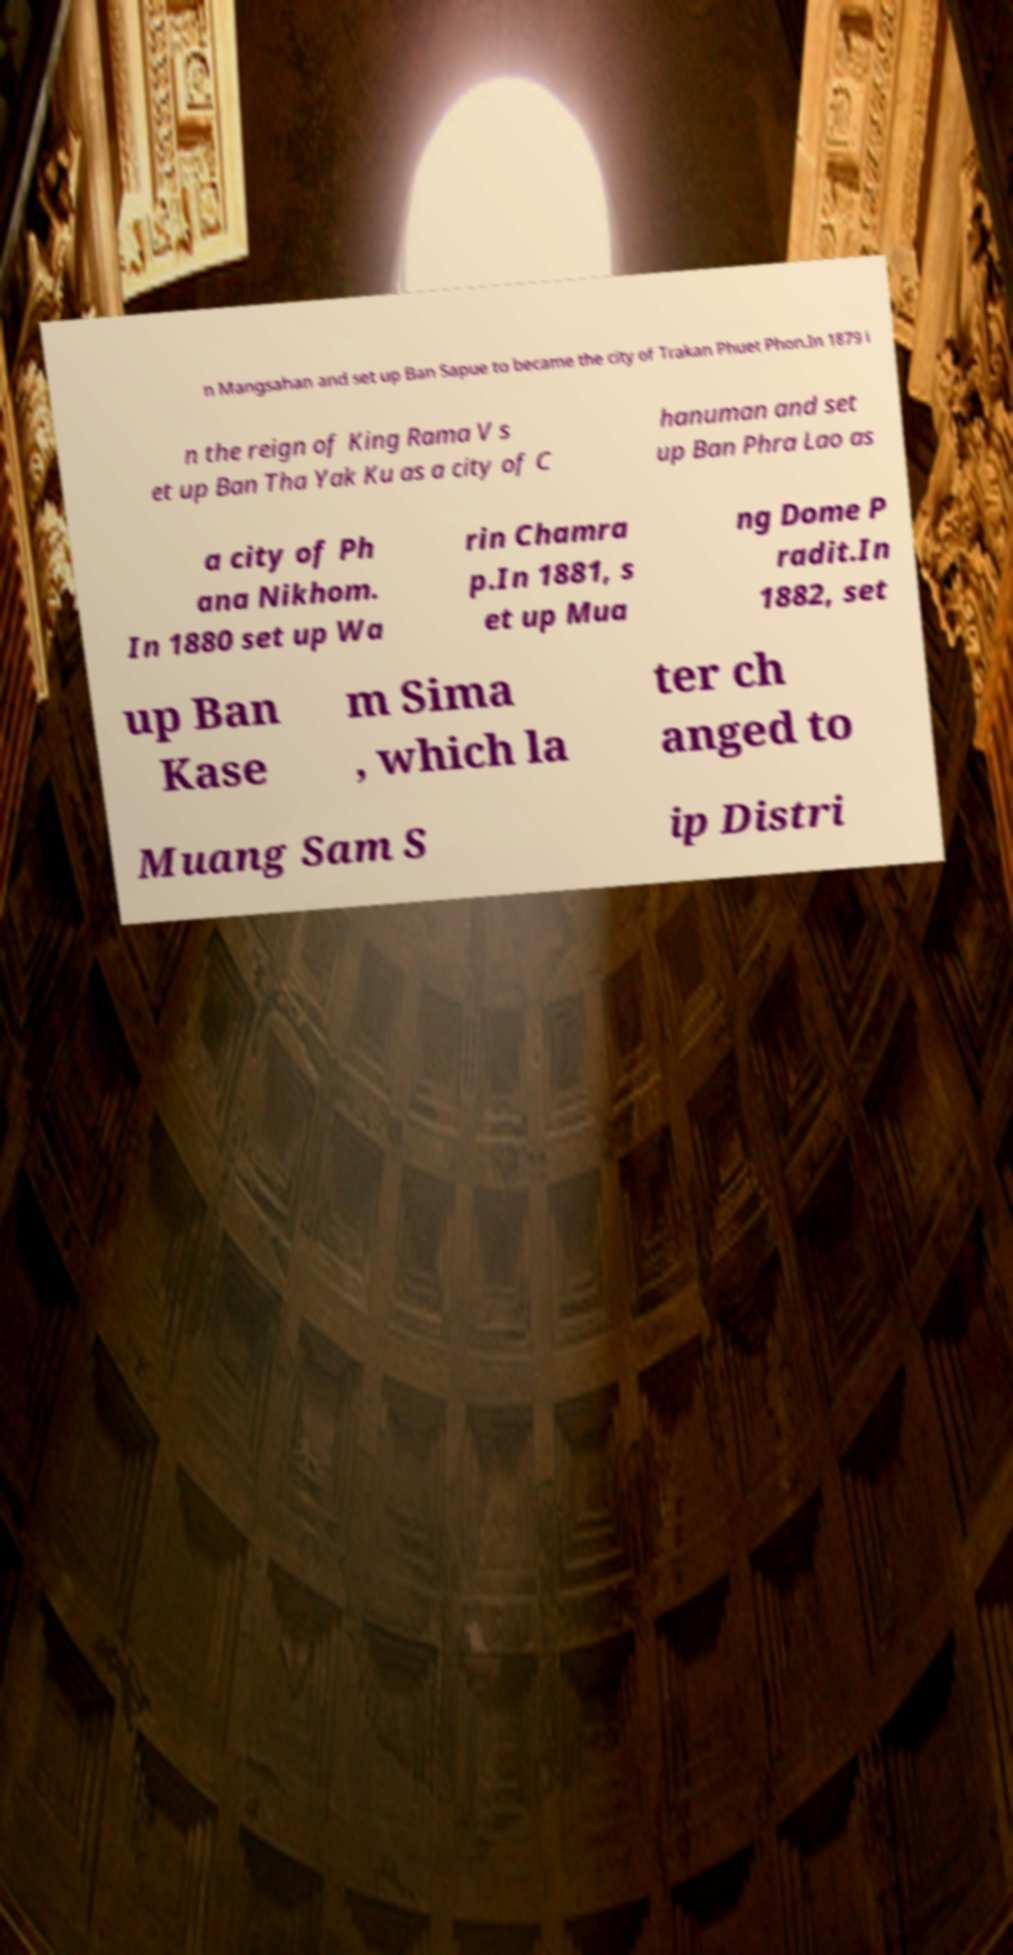What messages or text are displayed in this image? I need them in a readable, typed format. n Mangsahan and set up Ban Sapue to became the city of Trakan Phuet Phon.In 1879 i n the reign of King Rama V s et up Ban Tha Yak Ku as a city of C hanuman and set up Ban Phra Lao as a city of Ph ana Nikhom. In 1880 set up Wa rin Chamra p.In 1881, s et up Mua ng Dome P radit.In 1882, set up Ban Kase m Sima , which la ter ch anged to Muang Sam S ip Distri 